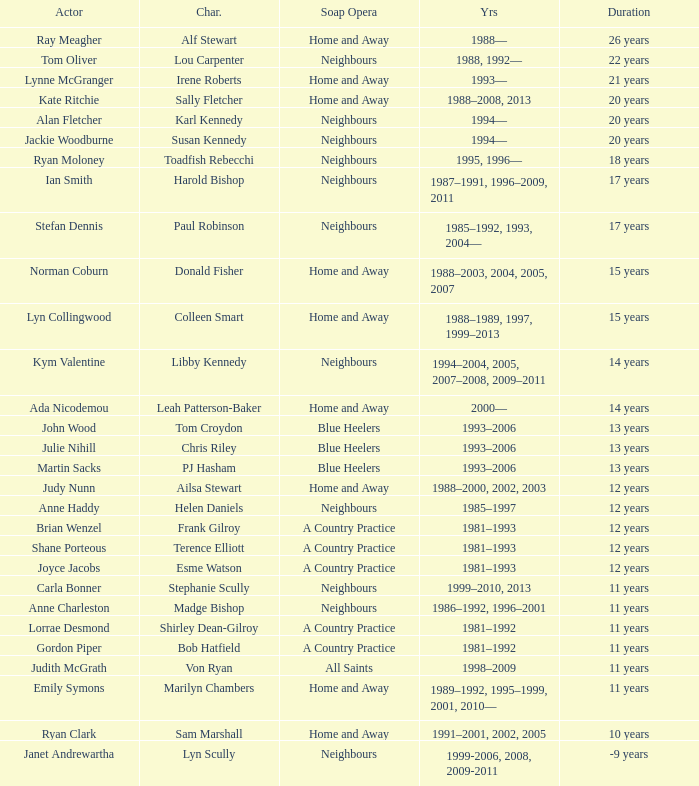How long did Joyce Jacobs portray her character on her show? 12 years. 